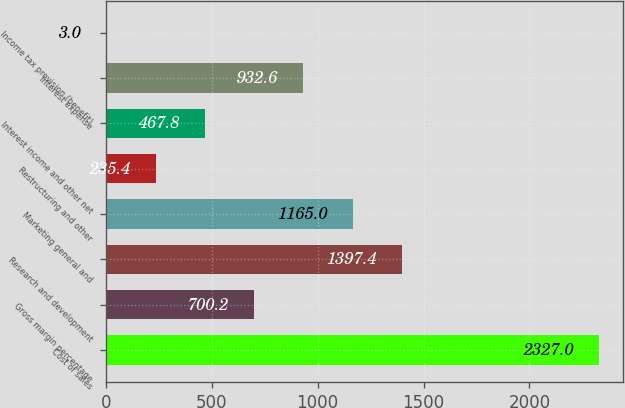<chart> <loc_0><loc_0><loc_500><loc_500><bar_chart><fcel>Cost of sales<fcel>Gross margin percentage<fcel>Research and development<fcel>Marketing general and<fcel>Restructuring and other<fcel>Interest income and other net<fcel>Interest expense<fcel>Income tax provision (benefit)<nl><fcel>2327<fcel>700.2<fcel>1397.4<fcel>1165<fcel>235.4<fcel>467.8<fcel>932.6<fcel>3<nl></chart> 